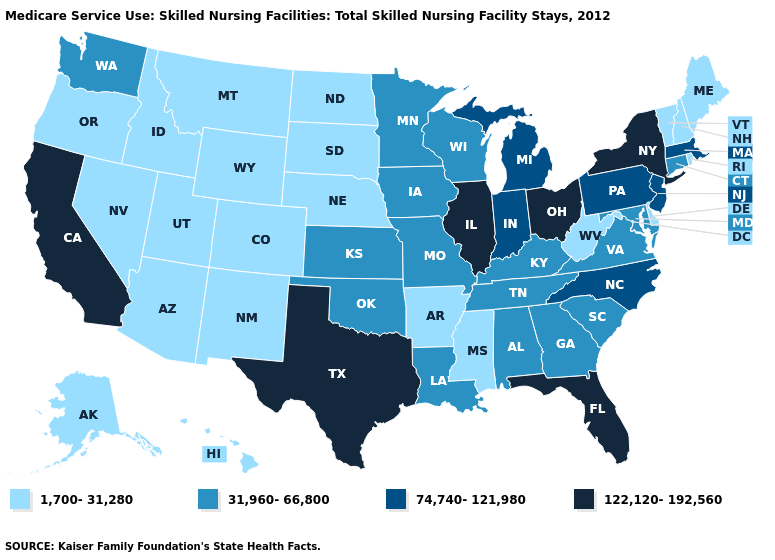What is the highest value in the USA?
Quick response, please. 122,120-192,560. What is the lowest value in the West?
Quick response, please. 1,700-31,280. What is the value of California?
Concise answer only. 122,120-192,560. Does Nevada have the same value as Arizona?
Concise answer only. Yes. Does Washington have the lowest value in the West?
Quick response, please. No. What is the value of Louisiana?
Be succinct. 31,960-66,800. Which states have the lowest value in the USA?
Quick response, please. Alaska, Arizona, Arkansas, Colorado, Delaware, Hawaii, Idaho, Maine, Mississippi, Montana, Nebraska, Nevada, New Hampshire, New Mexico, North Dakota, Oregon, Rhode Island, South Dakota, Utah, Vermont, West Virginia, Wyoming. Does the first symbol in the legend represent the smallest category?
Short answer required. Yes. What is the value of North Carolina?
Write a very short answer. 74,740-121,980. Is the legend a continuous bar?
Be succinct. No. Among the states that border Utah , which have the lowest value?
Be succinct. Arizona, Colorado, Idaho, Nevada, New Mexico, Wyoming. What is the lowest value in the USA?
Write a very short answer. 1,700-31,280. What is the highest value in the MidWest ?
Concise answer only. 122,120-192,560. Does the first symbol in the legend represent the smallest category?
Give a very brief answer. Yes. What is the value of Oregon?
Be succinct. 1,700-31,280. 